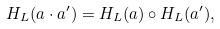<formula> <loc_0><loc_0><loc_500><loc_500>H _ { L } ( a \cdot a ^ { \prime } ) = H _ { L } ( a ) \circ H _ { L } ( a ^ { \prime } ) ,</formula> 